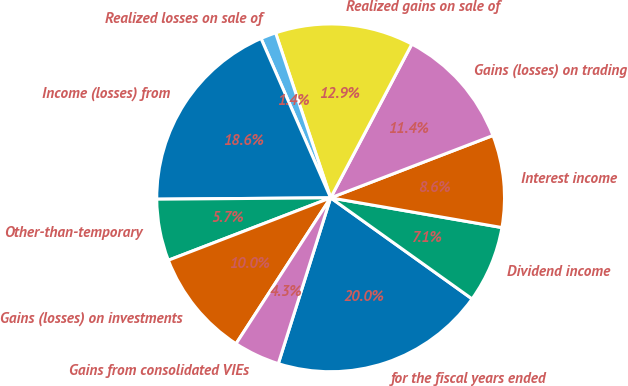Convert chart. <chart><loc_0><loc_0><loc_500><loc_500><pie_chart><fcel>for the fiscal years ended<fcel>Dividend income<fcel>Interest income<fcel>Gains (losses) on trading<fcel>Realized gains on sale of<fcel>Realized losses on sale of<fcel>Income (losses) from<fcel>Other-than-temporary<fcel>Gains (losses) on investments<fcel>Gains from consolidated VIEs<nl><fcel>19.99%<fcel>7.14%<fcel>8.57%<fcel>11.43%<fcel>12.86%<fcel>1.43%<fcel>18.57%<fcel>5.72%<fcel>10.0%<fcel>4.29%<nl></chart> 